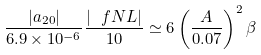<formula> <loc_0><loc_0><loc_500><loc_500>\frac { | a _ { 2 0 } | } { 6 . 9 \times 1 0 ^ { - 6 } } \frac { | \ f N L | } { 1 0 } \simeq 6 \left ( \frac { A } { 0 . 0 7 } \right ) ^ { 2 } \beta</formula> 